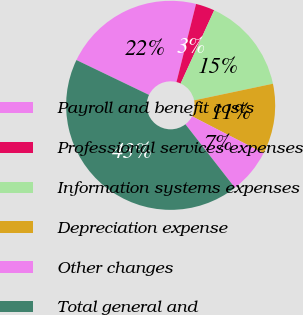Convert chart. <chart><loc_0><loc_0><loc_500><loc_500><pie_chart><fcel>Payroll and benefit costs<fcel>Professional services expenses<fcel>Information systems expenses<fcel>Depreciation expense<fcel>Other changes<fcel>Total general and<nl><fcel>21.78%<fcel>2.93%<fcel>14.85%<fcel>10.88%<fcel>6.9%<fcel>42.67%<nl></chart> 